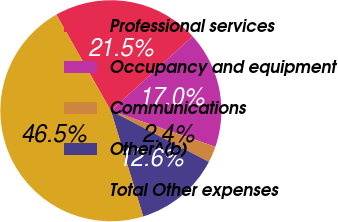<chart> <loc_0><loc_0><loc_500><loc_500><pie_chart><fcel>Professional services<fcel>Occupancy and equipment<fcel>Communications<fcel>Other^(b)<fcel>Total Other expenses<nl><fcel>21.46%<fcel>17.04%<fcel>2.36%<fcel>12.63%<fcel>46.51%<nl></chart> 